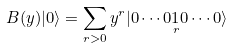<formula> <loc_0><loc_0><loc_500><loc_500>B ( y ) | 0 \rangle = \sum _ { r > 0 } y ^ { r } | 0 \cdots 0 \underset { r } { 1 } 0 \cdots 0 \rangle</formula> 